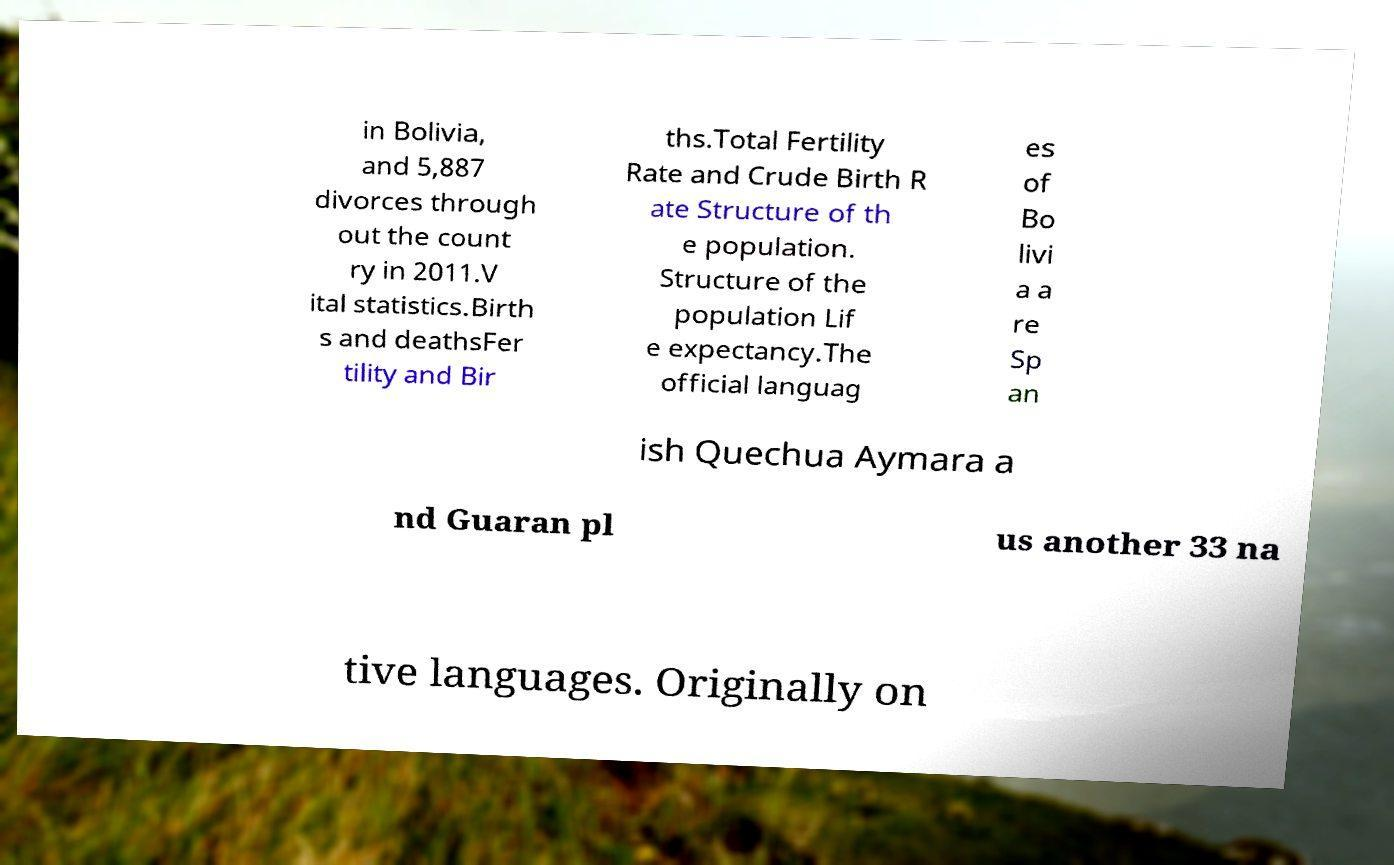Please read and relay the text visible in this image. What does it say? in Bolivia, and 5,887 divorces through out the count ry in 2011.V ital statistics.Birth s and deathsFer tility and Bir ths.Total Fertility Rate and Crude Birth R ate Structure of th e population. Structure of the population Lif e expectancy.The official languag es of Bo livi a a re Sp an ish Quechua Aymara a nd Guaran pl us another 33 na tive languages. Originally on 